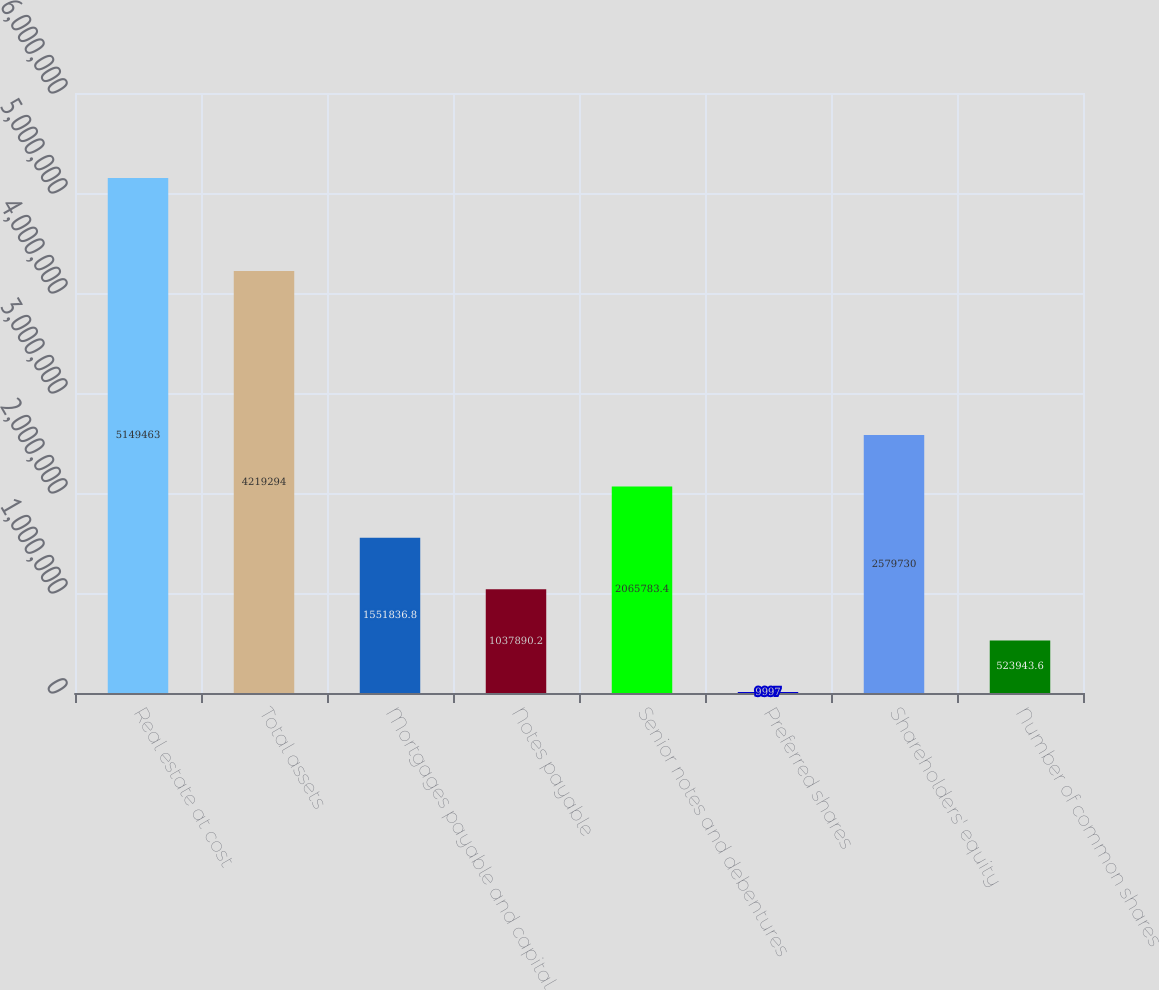Convert chart. <chart><loc_0><loc_0><loc_500><loc_500><bar_chart><fcel>Real estate at cost<fcel>Total assets<fcel>Mortgages payable and capital<fcel>Notes payable<fcel>Senior notes and debentures<fcel>Preferred shares<fcel>Shareholders' equity<fcel>Number of common shares<nl><fcel>5.14946e+06<fcel>4.21929e+06<fcel>1.55184e+06<fcel>1.03789e+06<fcel>2.06578e+06<fcel>9997<fcel>2.57973e+06<fcel>523944<nl></chart> 